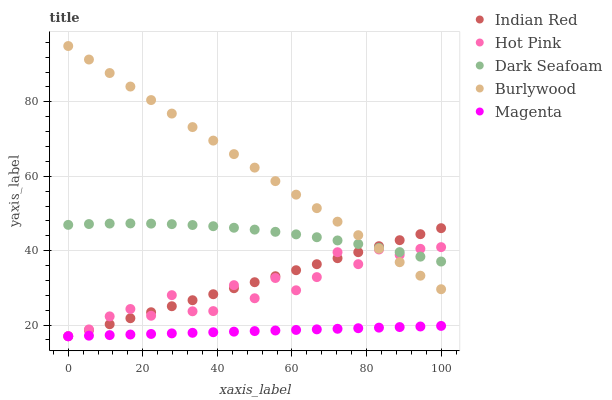Does Magenta have the minimum area under the curve?
Answer yes or no. Yes. Does Burlywood have the maximum area under the curve?
Answer yes or no. Yes. Does Dark Seafoam have the minimum area under the curve?
Answer yes or no. No. Does Dark Seafoam have the maximum area under the curve?
Answer yes or no. No. Is Magenta the smoothest?
Answer yes or no. Yes. Is Hot Pink the roughest?
Answer yes or no. Yes. Is Dark Seafoam the smoothest?
Answer yes or no. No. Is Dark Seafoam the roughest?
Answer yes or no. No. Does Hot Pink have the lowest value?
Answer yes or no. Yes. Does Dark Seafoam have the lowest value?
Answer yes or no. No. Does Burlywood have the highest value?
Answer yes or no. Yes. Does Dark Seafoam have the highest value?
Answer yes or no. No. Is Magenta less than Dark Seafoam?
Answer yes or no. Yes. Is Burlywood greater than Magenta?
Answer yes or no. Yes. Does Dark Seafoam intersect Hot Pink?
Answer yes or no. Yes. Is Dark Seafoam less than Hot Pink?
Answer yes or no. No. Is Dark Seafoam greater than Hot Pink?
Answer yes or no. No. Does Magenta intersect Dark Seafoam?
Answer yes or no. No. 